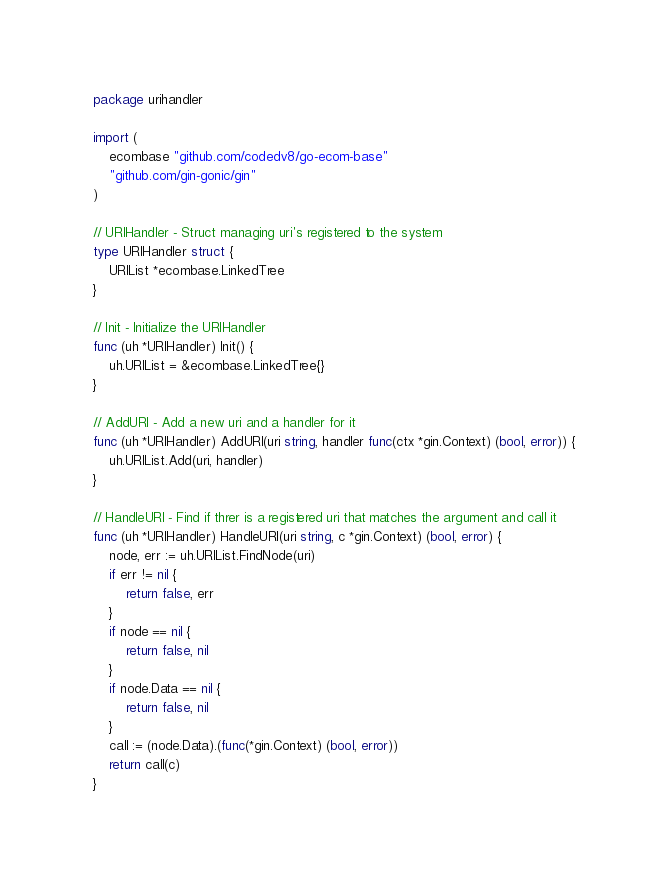Convert code to text. <code><loc_0><loc_0><loc_500><loc_500><_Go_>package urihandler

import (
	ecombase "github.com/codedv8/go-ecom-base"
	"github.com/gin-gonic/gin"
)

// URIHandler - Struct managing uri's registered to the system
type URIHandler struct {
	URIList *ecombase.LinkedTree
}

// Init - Initialize the URIHandler
func (uh *URIHandler) Init() {
	uh.URIList = &ecombase.LinkedTree{}
}

// AddURI - Add a new uri and a handler for it
func (uh *URIHandler) AddURI(uri string, handler func(ctx *gin.Context) (bool, error)) {
	uh.URIList.Add(uri, handler)
}

// HandleURI - Find if threr is a registered uri that matches the argument and call it
func (uh *URIHandler) HandleURI(uri string, c *gin.Context) (bool, error) {
	node, err := uh.URIList.FindNode(uri)
	if err != nil {
		return false, err
	}
	if node == nil {
		return false, nil
	}
	if node.Data == nil {
		return false, nil
	}
	call := (node.Data).(func(*gin.Context) (bool, error))
	return call(c)
}
</code> 